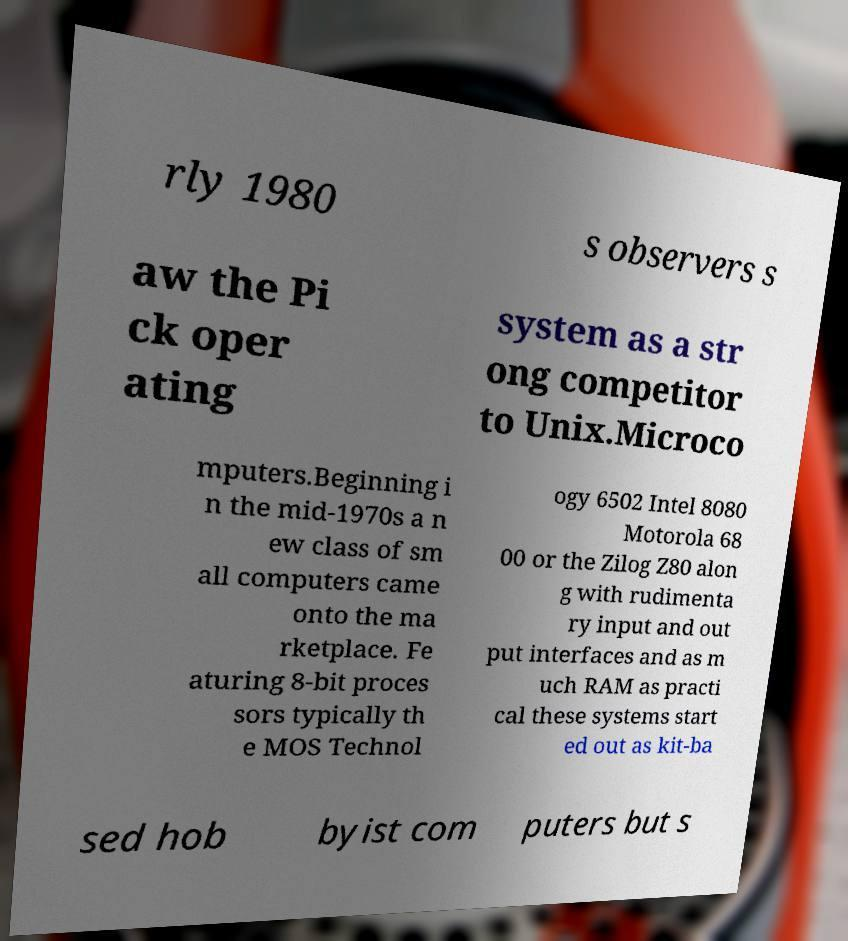Please identify and transcribe the text found in this image. rly 1980 s observers s aw the Pi ck oper ating system as a str ong competitor to Unix.Microco mputers.Beginning i n the mid-1970s a n ew class of sm all computers came onto the ma rketplace. Fe aturing 8-bit proces sors typically th e MOS Technol ogy 6502 Intel 8080 Motorola 68 00 or the Zilog Z80 alon g with rudimenta ry input and out put interfaces and as m uch RAM as practi cal these systems start ed out as kit-ba sed hob byist com puters but s 